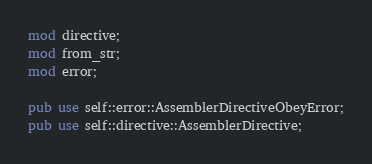<code> <loc_0><loc_0><loc_500><loc_500><_Rust_>mod directive;
mod from_str;
mod error;

pub use self::error::AssemblerDirectiveObeyError;
pub use self::directive::AssemblerDirective;
</code> 